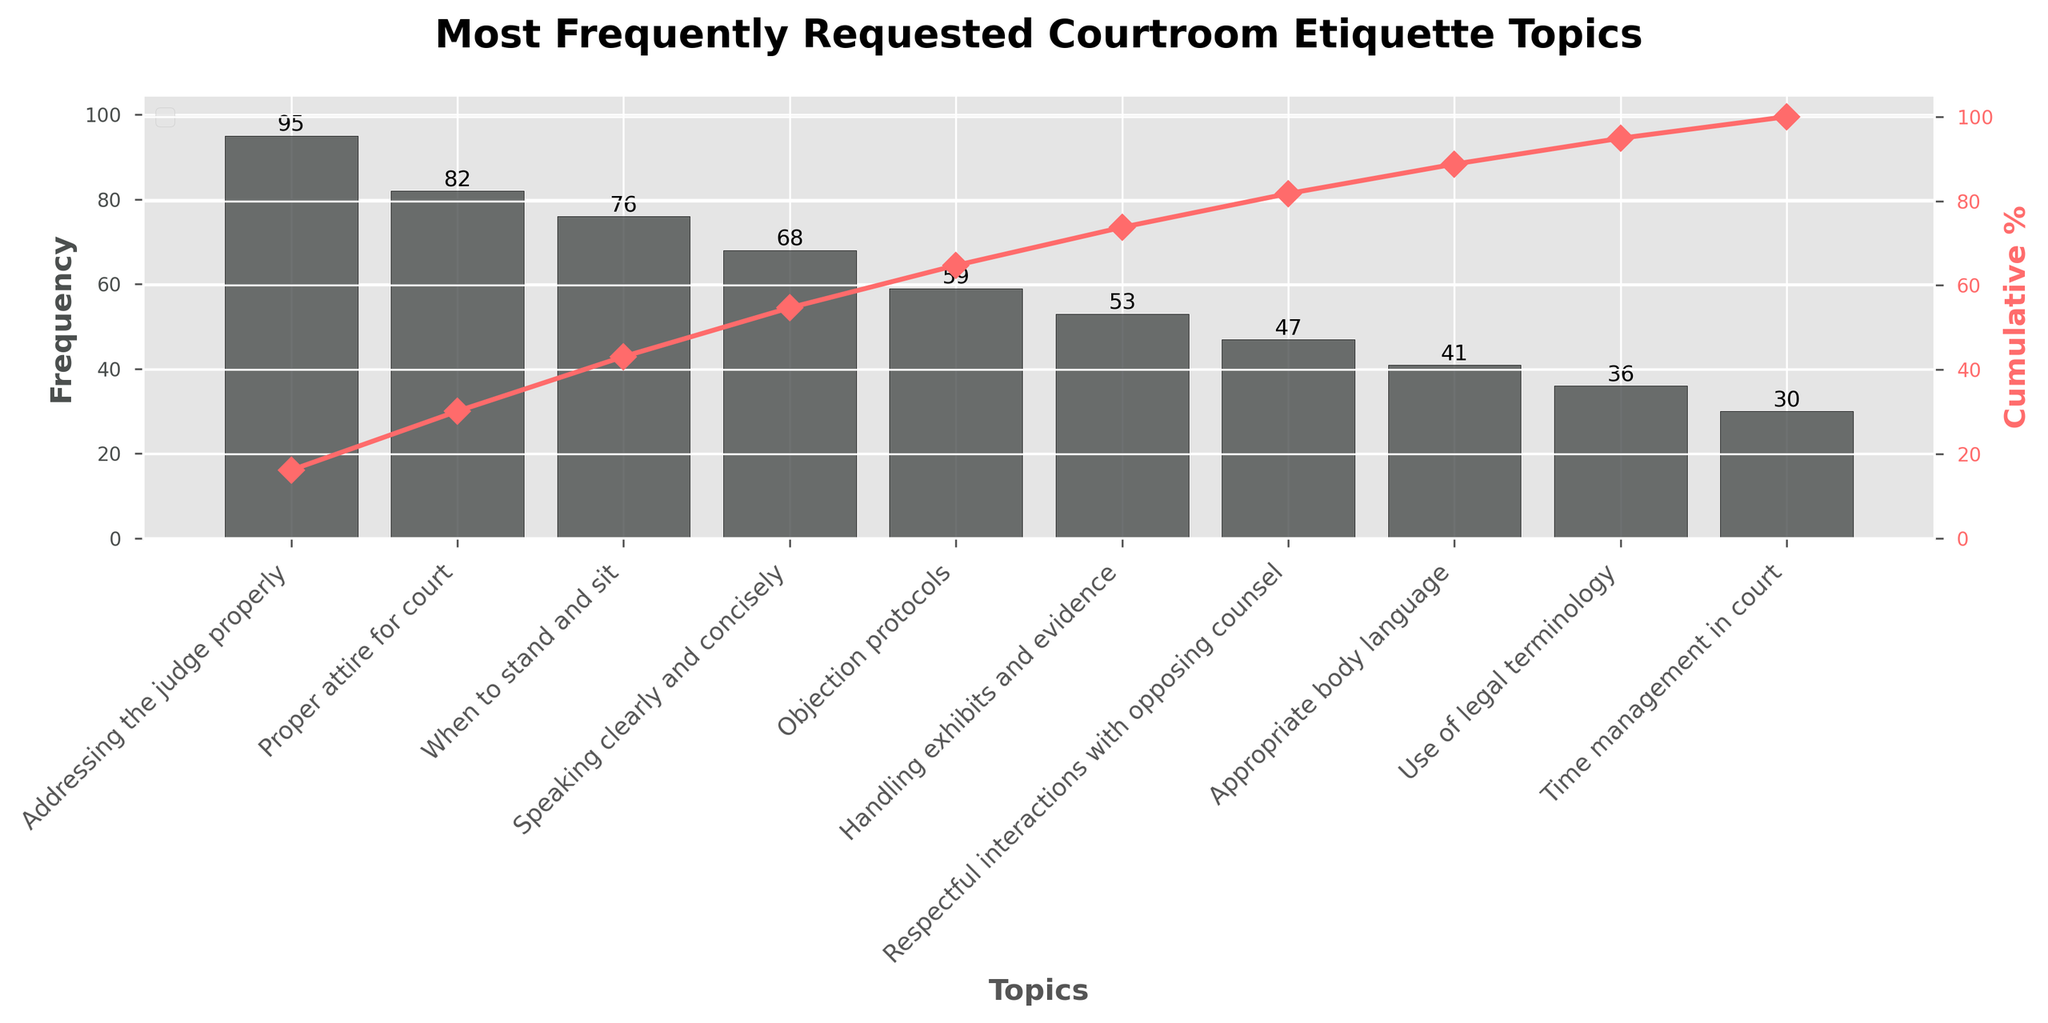What is the title of the figure? The title of the figure is prominently displayed at the top. It reads "Most Frequently Requested Courtroom Etiquette Topics".
Answer: Most Frequently Requested Courtroom Etiquette Topics How many topics are listed in the figure? Count the number of bars in the bar chart. There are 10 bars, each representing a distinct topic.
Answer: 10 Which topic has the highest frequency of requests? Look for the tallest bar in the bar chart. The tallest bar corresponds to the "Addressing the judge properly" topic.
Answer: Addressing the judge properly What is the cumulative percentage for the topic "Proper attire for court"? Find the point corresponding to "Proper attire for court" on the line plot and check its cumulative percentage value.
Answer: Approximately 32% What is the total frequency of the top three requested topics? Sum the frequencies of "Addressing the judge properly" (95), "Proper attire for court" (82), and "When to stand and sit" (76). \( 95 + 82 + 76 = 253 \)
Answer: 253 What is the difference in frequency between "Speaking clearly and concisely" and "Objection protocols"? Subtract the frequency of "Objection protocols" (59) from "Speaking clearly and concisely" (68). \( 68 - 59 = 9 \)
Answer: 9 Which topics have a frequency less than 50? Identify bars with heights below 50. The topics are "Respectful interactions with opposing counsel" (47), "Appropriate body language" (41), "Use of legal terminology" (36), and "Time management in court" (30).
Answer: Respectful interactions with opposing counsel, Appropriate body language, Use of legal terminology, Time management in court What cumulative percentage milestone is first reached by "Handling exhibits and evidence"? Follow the cumulative percentage line plot and identify where "Handling exhibits and evidence" falls. It is the first topic to reach over 60%.
Answer: Over 60% What is the cumulative percentage after including the topic "Objection protocols"? Look at the cumulative percentage line plot value for "Objection protocols", which is about 76%.
Answer: Approximately 76% Which topic's frequency is closest to but not exceeding 50? Check the bar corresponding to "Respectful interactions with opposing counsel", which has a frequency of 47, making it the closest to 50 without surpassing it.
Answer: Respectful interactions with opposing counsel 